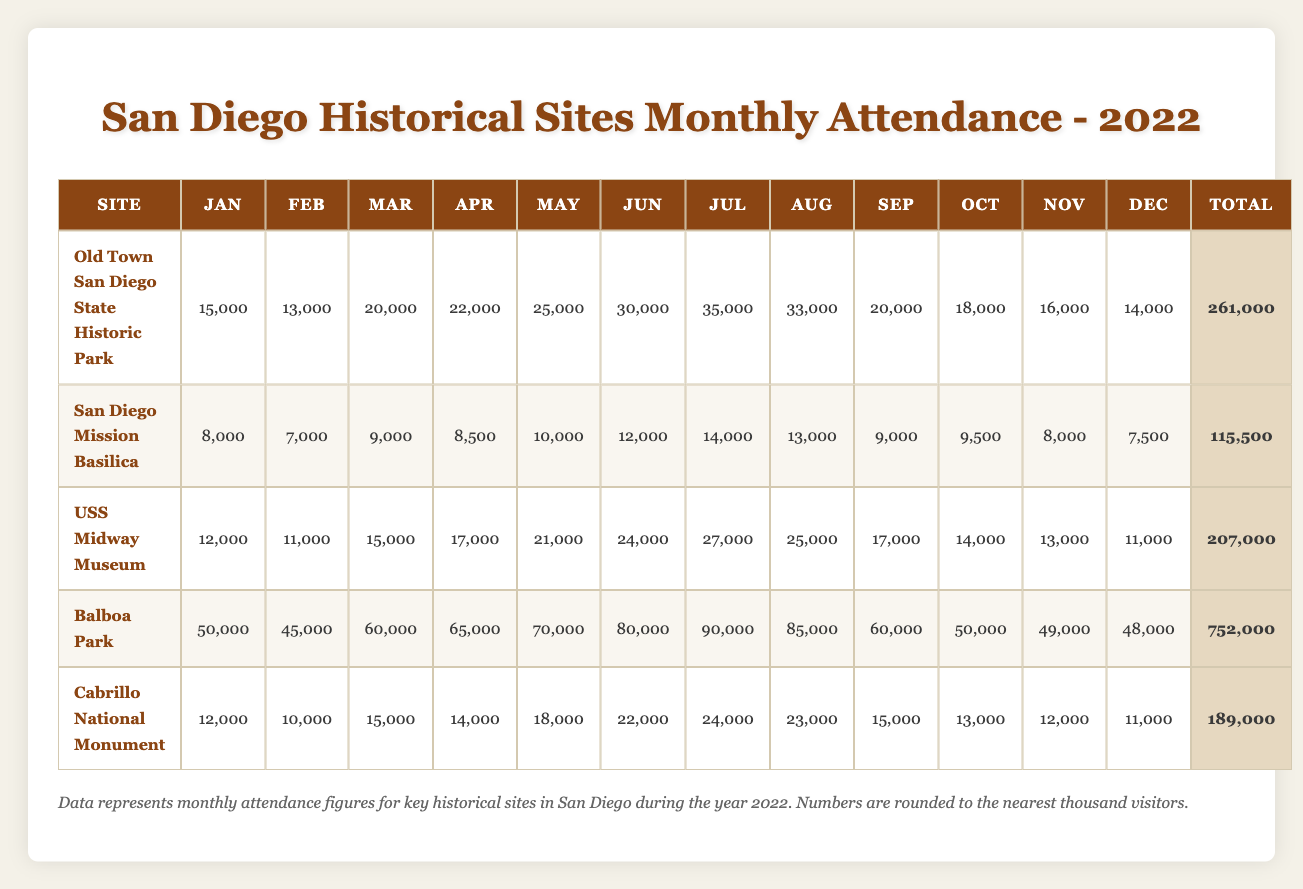What was the highest monthly attendance at Balboa Park? Looking at the table, the monthly attendance for Balboa Park peaked in July with 90,000 visitors.
Answer: 90,000 Which site had the lowest total attendance in 2022? When examining the total attendance column, San Diego Mission Basilica had the lowest total with 115,500 visitors throughout the year.
Answer: 115,500 What is the average monthly attendance for Cabrillo National Monument? To find the average, first sum the monthly attendance values for Cabrillo National Monument: 12,000 + 10,000 + 15,000 + 14,000 + 18,000 + 22,000 + 24,000 + 23,000 + 15,000 + 13,000 + 12,000 + 11,000 = 189,000. Then, divide by 12 months: 189,000 / 12 = 15,750.
Answer: 15,750 Did the USS Midway Museum have more visitors in July than in June? Comparing the attendance figures, the USS Midway Museum had 27,000 visitors in July and 24,000 in June, indicating that July's attendance was higher.
Answer: Yes What was the difference in attendance between the highest and lowest months for Old Town San Diego State Historic Park? The highest attendance occurred in July with 35,000 visitors and the lowest in February with 13,000 visitors. The difference is calculated as 35,000 - 13,000 = 22,000.
Answer: 22,000 